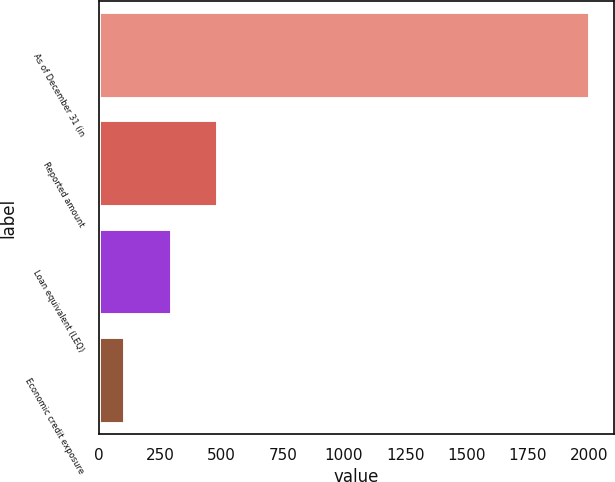Convert chart to OTSL. <chart><loc_0><loc_0><loc_500><loc_500><bar_chart><fcel>As of December 31 (in<fcel>Reported amount<fcel>Loan equivalent (LEQ)<fcel>Economic credit exposure<nl><fcel>2003<fcel>486.2<fcel>296.6<fcel>107<nl></chart> 